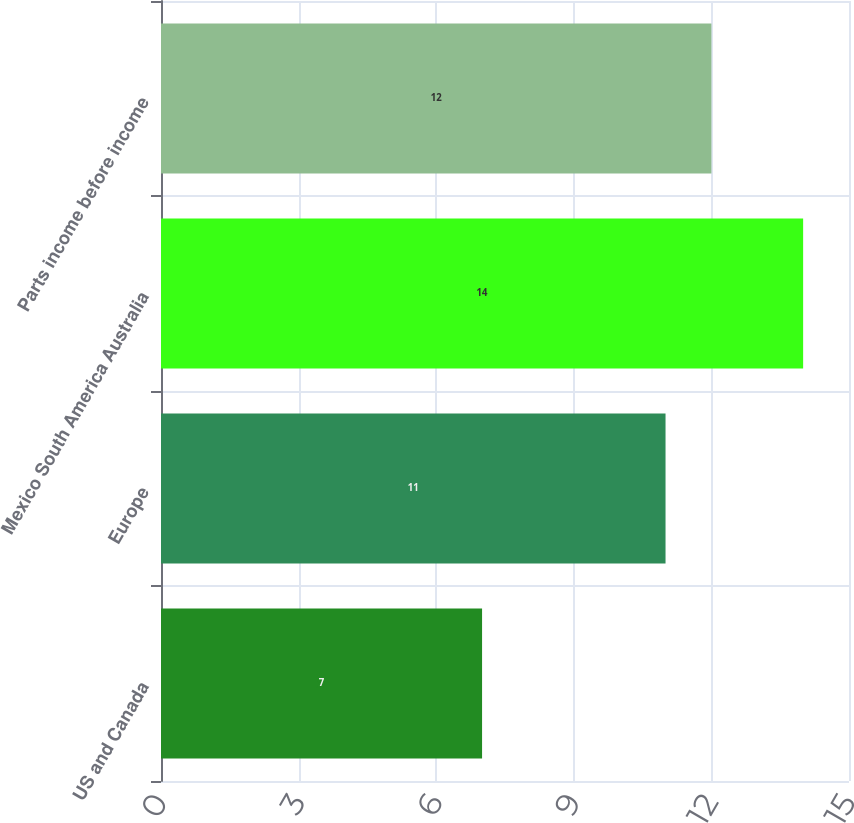Convert chart. <chart><loc_0><loc_0><loc_500><loc_500><bar_chart><fcel>US and Canada<fcel>Europe<fcel>Mexico South America Australia<fcel>Parts income before income<nl><fcel>7<fcel>11<fcel>14<fcel>12<nl></chart> 